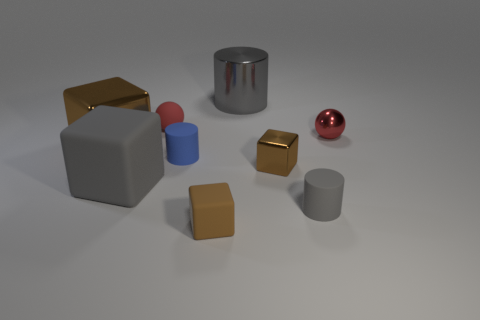Subtract all brown balls. How many brown cubes are left? 3 Subtract 2 cubes. How many cubes are left? 2 Subtract all gray cubes. How many cubes are left? 3 Subtract all yellow blocks. Subtract all red spheres. How many blocks are left? 4 Add 1 metal things. How many objects exist? 10 Subtract all cubes. How many objects are left? 5 Subtract all tiny red metal balls. Subtract all big matte objects. How many objects are left? 7 Add 4 small shiny balls. How many small shiny balls are left? 5 Add 4 large blocks. How many large blocks exist? 6 Subtract 0 brown balls. How many objects are left? 9 